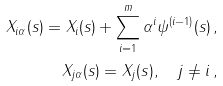Convert formula to latex. <formula><loc_0><loc_0><loc_500><loc_500>X _ { i \alpha } ( s ) = X _ { i } ( s ) + \sum _ { i = 1 } ^ { m } \alpha ^ { i } \psi ^ { ( i - 1 ) } ( s ) \, , \\ X _ { j \alpha } ( s ) = X _ { j } ( s ) , \quad j \neq i \, ,</formula> 